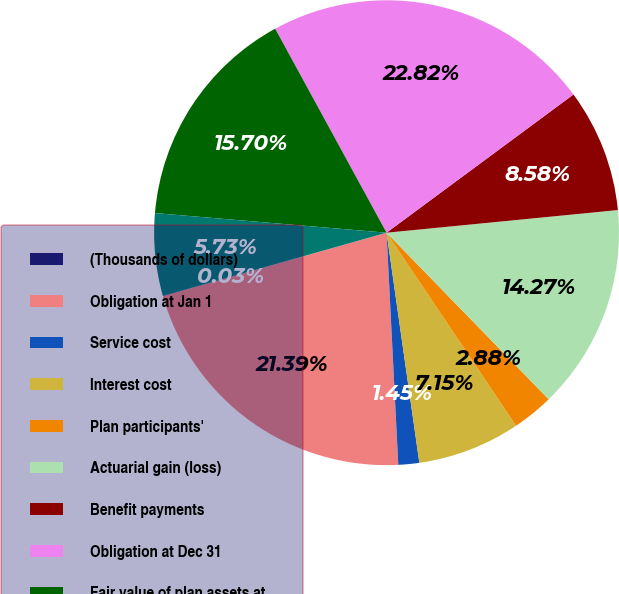Convert chart to OTSL. <chart><loc_0><loc_0><loc_500><loc_500><pie_chart><fcel>(Thousands of dollars)<fcel>Obligation at Jan 1<fcel>Service cost<fcel>Interest cost<fcel>Plan participants'<fcel>Actuarial gain (loss)<fcel>Benefit payments<fcel>Obligation at Dec 31<fcel>Fair value of plan assets at<fcel>Actual return on plan assets<nl><fcel>0.03%<fcel>21.39%<fcel>1.45%<fcel>7.15%<fcel>2.88%<fcel>14.27%<fcel>8.58%<fcel>22.82%<fcel>15.7%<fcel>5.73%<nl></chart> 